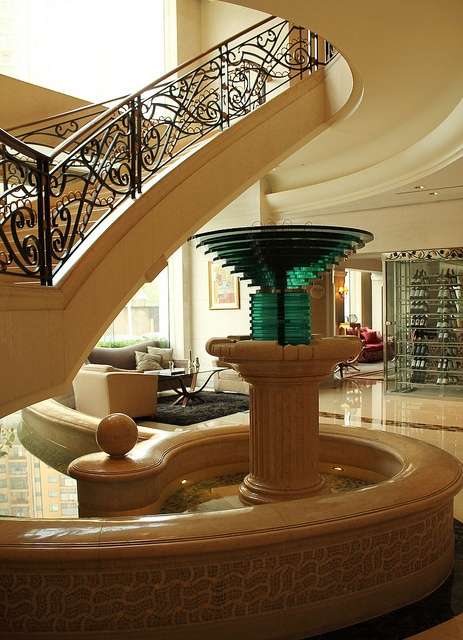Describe the objects in this image and their specific colors. I can see vase in ivory, black, darkgreen, olive, and gray tones, chair in ivory, maroon, and tan tones, couch in ivory, maroon, and tan tones, couch in ivory, tan, maroon, and gray tones, and bottle in ivory, black, darkgreen, gray, and olive tones in this image. 